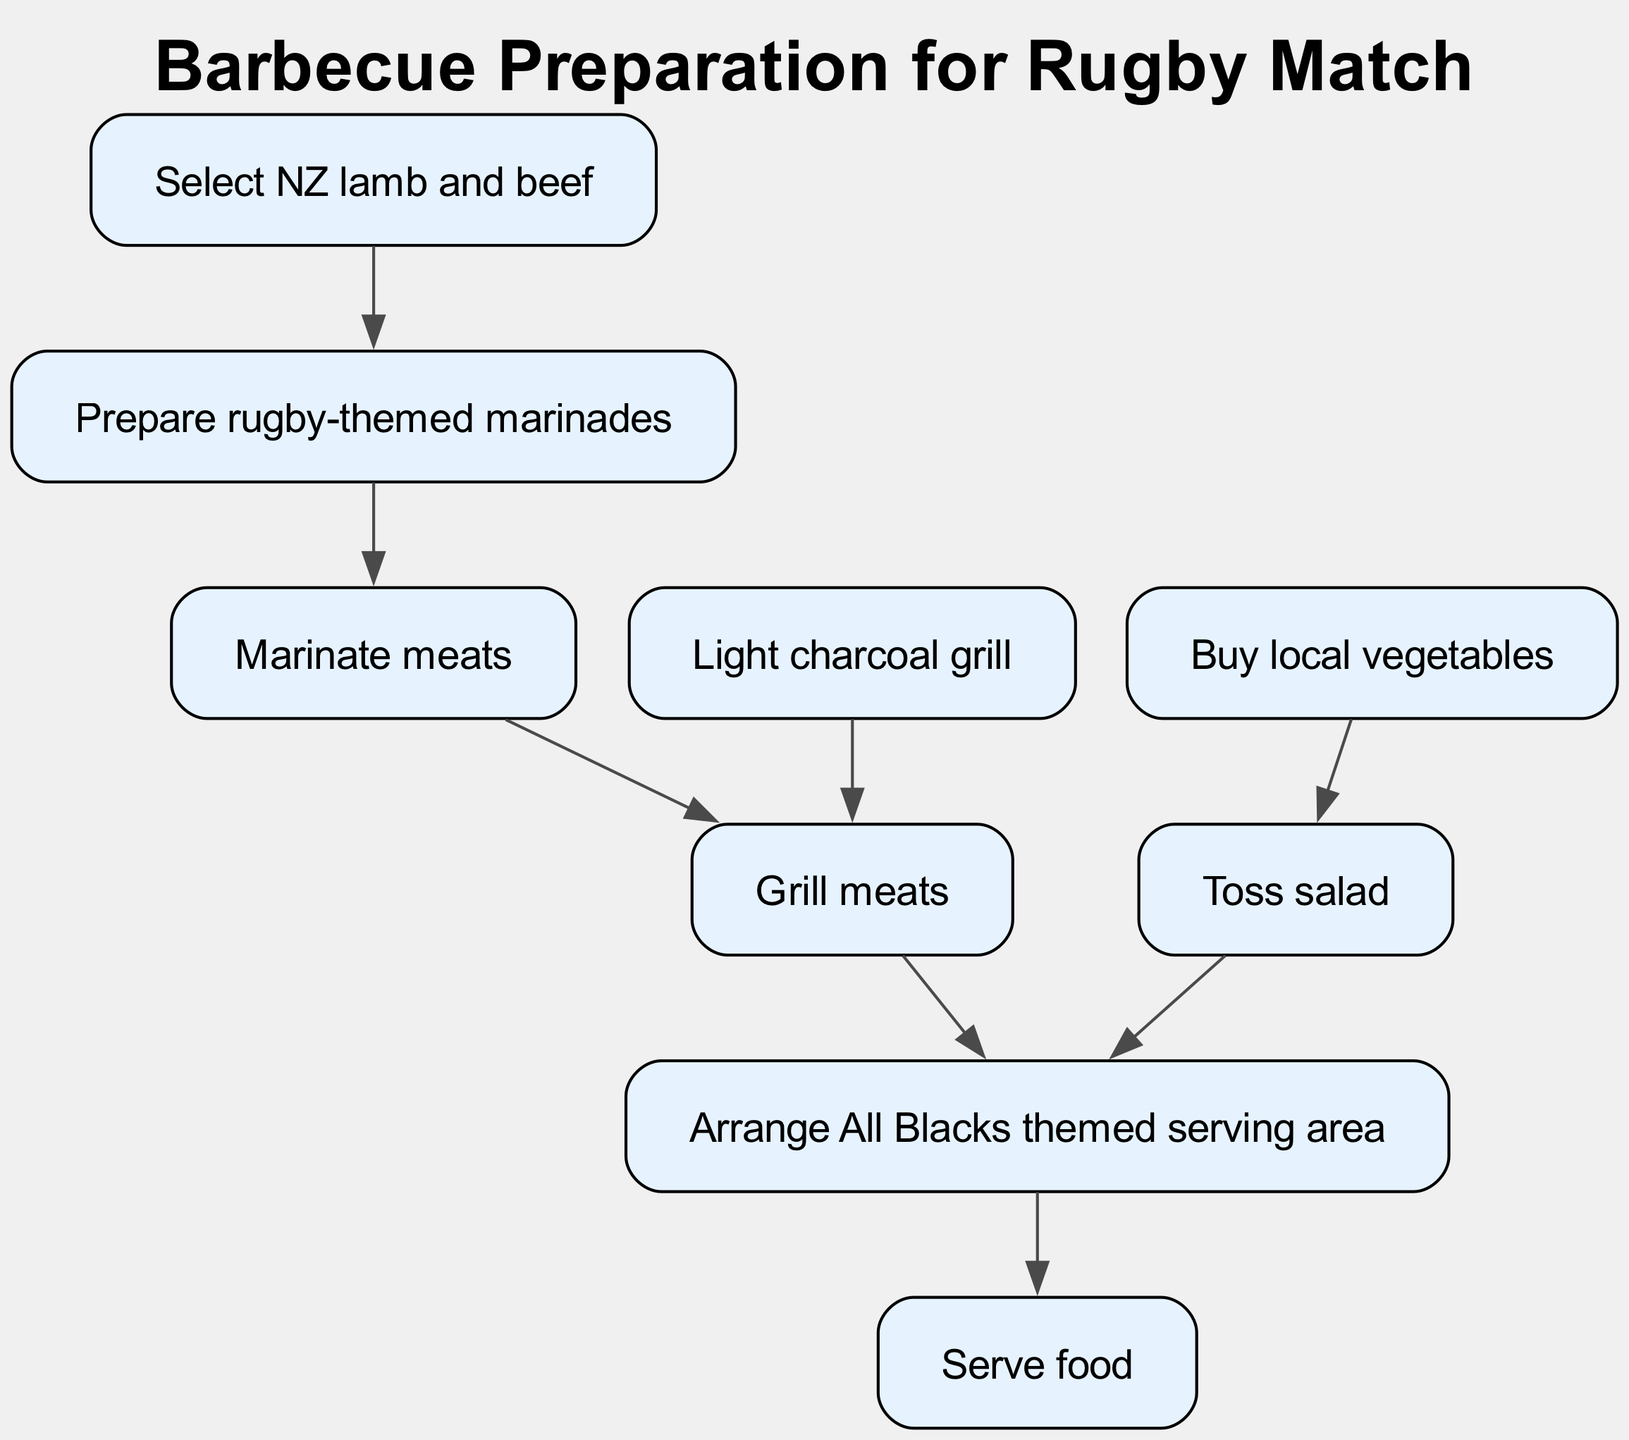What is the first step in the barbecue meal preparation workflow? The first step is to "Select NZ lamb and beef", which is the initial action in the directed graph leading to the marinades preparation.
Answer: Select NZ lamb and beef How many nodes are in the diagram? By counting all distinct actions or elements represented in the directed graph, we find there are 8 nodes in total.
Answer: 8 What follows after "Marinate meats"? After "Marinate meats", the next action is "Grill meats", as seen by the directed edge leading directly from "Marinate meats" to "Grill meats".
Answer: Grill meats Which two actions lead to arranging the All Blacks themed serving area? The actions "Grill meats" and "Toss salad" both lead to "Arrange All Blacks themed serving area", as indicated by the edges pointing towards that node.
Answer: Grill meats, Toss salad How many edges are in the diagram? The diagram contains 7 edges connecting various nodes in the barbecue workflow.
Answer: 7 What is the final action in the barbecue preparation process? The last step in the workflow is "Serve food", which is the concluding action that follows the arrangement of the serving area.
Answer: Serve food What is the connection between "Light charcoal grill" and the subsequent actions? "Light charcoal grill" connects directly to "Grill meats", indicating that lighting the grill is a necessary step before grilling, therefore influencing that action.
Answer: Grill meats Which action must be completed before marinating the meats? Before the meats can be marinated, the "Prepare rugby-themed marinades" must be completed, as indicated by the directed flow in the graph.
Answer: Prepare rugby-themed marinades What is the purpose of the node "Toss salad"? The purpose of the node "Toss salad" is to prepare a fresh side dish that directly contributes to the serving process when it leads to "Arrange All Blacks themed serving area".
Answer: Prepare a fresh side dish 